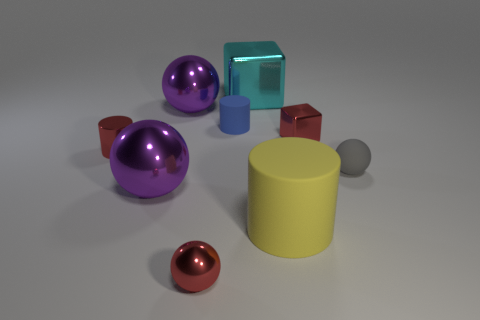Can you tell me the colors of all the objects in this image? Certainly! In the image, there are objects in purple, red, teal, blue, brown, yellow, and gray colors. 